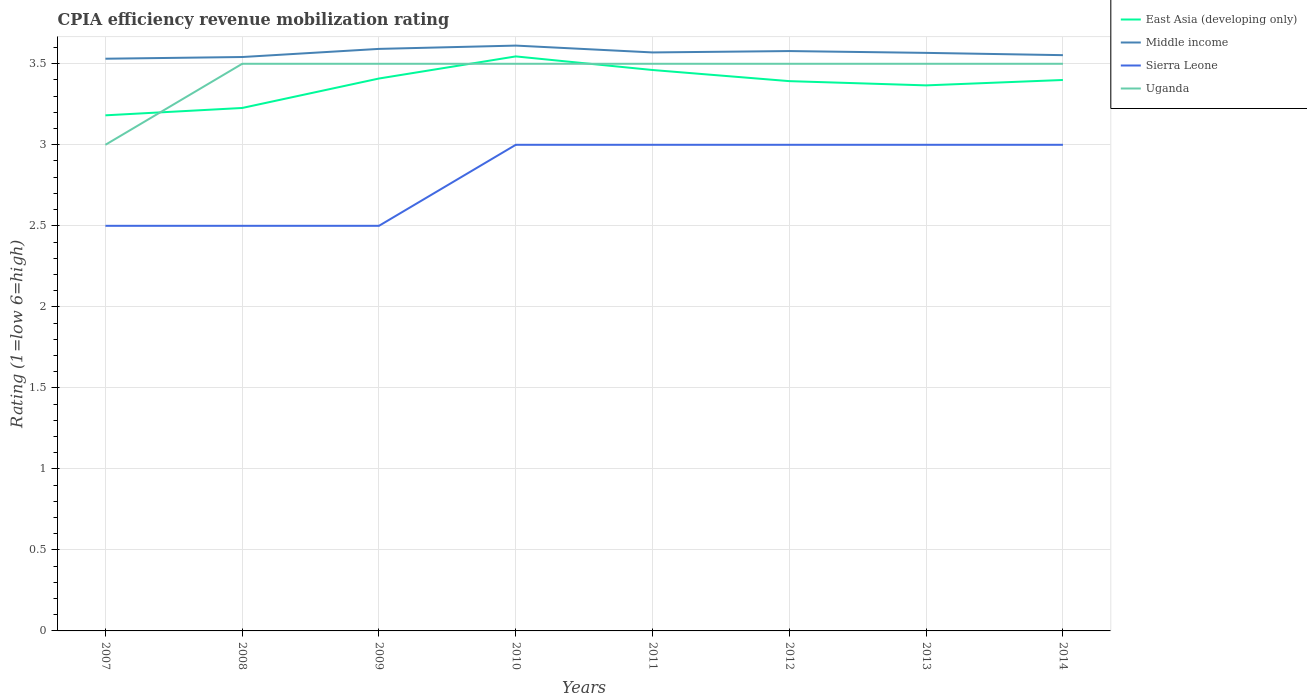How many different coloured lines are there?
Make the answer very short. 4. Does the line corresponding to Middle income intersect with the line corresponding to East Asia (developing only)?
Provide a short and direct response. No. Is the number of lines equal to the number of legend labels?
Provide a succinct answer. Yes. Across all years, what is the maximum CPIA rating in Sierra Leone?
Make the answer very short. 2.5. In which year was the CPIA rating in Sierra Leone maximum?
Provide a short and direct response. 2007. What is the difference between the highest and the second highest CPIA rating in East Asia (developing only)?
Offer a terse response. 0.36. What is the difference between the highest and the lowest CPIA rating in Middle income?
Offer a very short reply. 4. How many years are there in the graph?
Your answer should be compact. 8. What is the difference between two consecutive major ticks on the Y-axis?
Give a very brief answer. 0.5. Does the graph contain grids?
Your answer should be compact. Yes. Where does the legend appear in the graph?
Keep it short and to the point. Top right. What is the title of the graph?
Offer a terse response. CPIA efficiency revenue mobilization rating. What is the label or title of the X-axis?
Your answer should be very brief. Years. What is the Rating (1=low 6=high) of East Asia (developing only) in 2007?
Ensure brevity in your answer.  3.18. What is the Rating (1=low 6=high) of Middle income in 2007?
Ensure brevity in your answer.  3.53. What is the Rating (1=low 6=high) of Uganda in 2007?
Keep it short and to the point. 3. What is the Rating (1=low 6=high) in East Asia (developing only) in 2008?
Your answer should be very brief. 3.23. What is the Rating (1=low 6=high) in Middle income in 2008?
Ensure brevity in your answer.  3.54. What is the Rating (1=low 6=high) of East Asia (developing only) in 2009?
Ensure brevity in your answer.  3.41. What is the Rating (1=low 6=high) in Middle income in 2009?
Make the answer very short. 3.59. What is the Rating (1=low 6=high) in East Asia (developing only) in 2010?
Give a very brief answer. 3.55. What is the Rating (1=low 6=high) of Middle income in 2010?
Make the answer very short. 3.61. What is the Rating (1=low 6=high) of East Asia (developing only) in 2011?
Keep it short and to the point. 3.46. What is the Rating (1=low 6=high) in Middle income in 2011?
Give a very brief answer. 3.57. What is the Rating (1=low 6=high) in Uganda in 2011?
Your response must be concise. 3.5. What is the Rating (1=low 6=high) in East Asia (developing only) in 2012?
Your response must be concise. 3.39. What is the Rating (1=low 6=high) in Middle income in 2012?
Your response must be concise. 3.58. What is the Rating (1=low 6=high) in Sierra Leone in 2012?
Offer a terse response. 3. What is the Rating (1=low 6=high) of Uganda in 2012?
Offer a terse response. 3.5. What is the Rating (1=low 6=high) of East Asia (developing only) in 2013?
Offer a terse response. 3.37. What is the Rating (1=low 6=high) of Middle income in 2013?
Your answer should be compact. 3.57. What is the Rating (1=low 6=high) of Sierra Leone in 2013?
Make the answer very short. 3. What is the Rating (1=low 6=high) in Uganda in 2013?
Your answer should be very brief. 3.5. What is the Rating (1=low 6=high) of East Asia (developing only) in 2014?
Keep it short and to the point. 3.4. What is the Rating (1=low 6=high) of Middle income in 2014?
Keep it short and to the point. 3.55. What is the Rating (1=low 6=high) in Uganda in 2014?
Keep it short and to the point. 3.5. Across all years, what is the maximum Rating (1=low 6=high) in East Asia (developing only)?
Your answer should be very brief. 3.55. Across all years, what is the maximum Rating (1=low 6=high) of Middle income?
Keep it short and to the point. 3.61. Across all years, what is the maximum Rating (1=low 6=high) in Sierra Leone?
Your response must be concise. 3. Across all years, what is the maximum Rating (1=low 6=high) of Uganda?
Your response must be concise. 3.5. Across all years, what is the minimum Rating (1=low 6=high) of East Asia (developing only)?
Keep it short and to the point. 3.18. Across all years, what is the minimum Rating (1=low 6=high) in Middle income?
Your answer should be compact. 3.53. Across all years, what is the minimum Rating (1=low 6=high) of Uganda?
Offer a very short reply. 3. What is the total Rating (1=low 6=high) of East Asia (developing only) in the graph?
Provide a short and direct response. 26.98. What is the total Rating (1=low 6=high) of Middle income in the graph?
Offer a very short reply. 28.55. What is the total Rating (1=low 6=high) in Sierra Leone in the graph?
Make the answer very short. 22.5. What is the difference between the Rating (1=low 6=high) in East Asia (developing only) in 2007 and that in 2008?
Your answer should be very brief. -0.05. What is the difference between the Rating (1=low 6=high) in Middle income in 2007 and that in 2008?
Offer a terse response. -0.01. What is the difference between the Rating (1=low 6=high) in East Asia (developing only) in 2007 and that in 2009?
Your response must be concise. -0.23. What is the difference between the Rating (1=low 6=high) in Middle income in 2007 and that in 2009?
Make the answer very short. -0.06. What is the difference between the Rating (1=low 6=high) of Sierra Leone in 2007 and that in 2009?
Provide a short and direct response. 0. What is the difference between the Rating (1=low 6=high) in Uganda in 2007 and that in 2009?
Your response must be concise. -0.5. What is the difference between the Rating (1=low 6=high) of East Asia (developing only) in 2007 and that in 2010?
Make the answer very short. -0.36. What is the difference between the Rating (1=low 6=high) in Middle income in 2007 and that in 2010?
Ensure brevity in your answer.  -0.08. What is the difference between the Rating (1=low 6=high) in Uganda in 2007 and that in 2010?
Make the answer very short. -0.5. What is the difference between the Rating (1=low 6=high) in East Asia (developing only) in 2007 and that in 2011?
Provide a short and direct response. -0.28. What is the difference between the Rating (1=low 6=high) of Middle income in 2007 and that in 2011?
Offer a terse response. -0.04. What is the difference between the Rating (1=low 6=high) of East Asia (developing only) in 2007 and that in 2012?
Your answer should be very brief. -0.21. What is the difference between the Rating (1=low 6=high) in Middle income in 2007 and that in 2012?
Offer a terse response. -0.05. What is the difference between the Rating (1=low 6=high) in Sierra Leone in 2007 and that in 2012?
Make the answer very short. -0.5. What is the difference between the Rating (1=low 6=high) of East Asia (developing only) in 2007 and that in 2013?
Your answer should be compact. -0.18. What is the difference between the Rating (1=low 6=high) of Middle income in 2007 and that in 2013?
Offer a very short reply. -0.04. What is the difference between the Rating (1=low 6=high) in East Asia (developing only) in 2007 and that in 2014?
Offer a terse response. -0.22. What is the difference between the Rating (1=low 6=high) in Middle income in 2007 and that in 2014?
Your answer should be compact. -0.02. What is the difference between the Rating (1=low 6=high) in Sierra Leone in 2007 and that in 2014?
Your answer should be very brief. -0.5. What is the difference between the Rating (1=low 6=high) of East Asia (developing only) in 2008 and that in 2009?
Make the answer very short. -0.18. What is the difference between the Rating (1=low 6=high) of Middle income in 2008 and that in 2009?
Your response must be concise. -0.05. What is the difference between the Rating (1=low 6=high) of Uganda in 2008 and that in 2009?
Make the answer very short. 0. What is the difference between the Rating (1=low 6=high) in East Asia (developing only) in 2008 and that in 2010?
Ensure brevity in your answer.  -0.32. What is the difference between the Rating (1=low 6=high) of Middle income in 2008 and that in 2010?
Your answer should be compact. -0.07. What is the difference between the Rating (1=low 6=high) of East Asia (developing only) in 2008 and that in 2011?
Offer a terse response. -0.23. What is the difference between the Rating (1=low 6=high) of Middle income in 2008 and that in 2011?
Your answer should be compact. -0.03. What is the difference between the Rating (1=low 6=high) in Sierra Leone in 2008 and that in 2011?
Give a very brief answer. -0.5. What is the difference between the Rating (1=low 6=high) of Uganda in 2008 and that in 2011?
Offer a terse response. 0. What is the difference between the Rating (1=low 6=high) in East Asia (developing only) in 2008 and that in 2012?
Provide a short and direct response. -0.17. What is the difference between the Rating (1=low 6=high) of Middle income in 2008 and that in 2012?
Your answer should be compact. -0.04. What is the difference between the Rating (1=low 6=high) of Uganda in 2008 and that in 2012?
Give a very brief answer. 0. What is the difference between the Rating (1=low 6=high) of East Asia (developing only) in 2008 and that in 2013?
Provide a succinct answer. -0.14. What is the difference between the Rating (1=low 6=high) in Middle income in 2008 and that in 2013?
Offer a very short reply. -0.03. What is the difference between the Rating (1=low 6=high) of East Asia (developing only) in 2008 and that in 2014?
Your answer should be compact. -0.17. What is the difference between the Rating (1=low 6=high) in Middle income in 2008 and that in 2014?
Your response must be concise. -0.01. What is the difference between the Rating (1=low 6=high) of Uganda in 2008 and that in 2014?
Ensure brevity in your answer.  0. What is the difference between the Rating (1=low 6=high) of East Asia (developing only) in 2009 and that in 2010?
Keep it short and to the point. -0.14. What is the difference between the Rating (1=low 6=high) in Middle income in 2009 and that in 2010?
Provide a short and direct response. -0.02. What is the difference between the Rating (1=low 6=high) of East Asia (developing only) in 2009 and that in 2011?
Your answer should be compact. -0.05. What is the difference between the Rating (1=low 6=high) of Middle income in 2009 and that in 2011?
Your answer should be compact. 0.02. What is the difference between the Rating (1=low 6=high) in East Asia (developing only) in 2009 and that in 2012?
Give a very brief answer. 0.02. What is the difference between the Rating (1=low 6=high) in Middle income in 2009 and that in 2012?
Provide a succinct answer. 0.01. What is the difference between the Rating (1=low 6=high) of East Asia (developing only) in 2009 and that in 2013?
Offer a very short reply. 0.04. What is the difference between the Rating (1=low 6=high) in Middle income in 2009 and that in 2013?
Provide a succinct answer. 0.02. What is the difference between the Rating (1=low 6=high) of East Asia (developing only) in 2009 and that in 2014?
Provide a short and direct response. 0.01. What is the difference between the Rating (1=low 6=high) in Middle income in 2009 and that in 2014?
Provide a succinct answer. 0.04. What is the difference between the Rating (1=low 6=high) of Sierra Leone in 2009 and that in 2014?
Provide a succinct answer. -0.5. What is the difference between the Rating (1=low 6=high) of Uganda in 2009 and that in 2014?
Your response must be concise. 0. What is the difference between the Rating (1=low 6=high) in East Asia (developing only) in 2010 and that in 2011?
Provide a short and direct response. 0.08. What is the difference between the Rating (1=low 6=high) in Middle income in 2010 and that in 2011?
Ensure brevity in your answer.  0.04. What is the difference between the Rating (1=low 6=high) of Sierra Leone in 2010 and that in 2011?
Offer a very short reply. 0. What is the difference between the Rating (1=low 6=high) of East Asia (developing only) in 2010 and that in 2012?
Offer a very short reply. 0.15. What is the difference between the Rating (1=low 6=high) of Middle income in 2010 and that in 2012?
Provide a succinct answer. 0.03. What is the difference between the Rating (1=low 6=high) in Sierra Leone in 2010 and that in 2012?
Offer a terse response. 0. What is the difference between the Rating (1=low 6=high) of Uganda in 2010 and that in 2012?
Offer a terse response. 0. What is the difference between the Rating (1=low 6=high) of East Asia (developing only) in 2010 and that in 2013?
Ensure brevity in your answer.  0.18. What is the difference between the Rating (1=low 6=high) in Middle income in 2010 and that in 2013?
Provide a succinct answer. 0.04. What is the difference between the Rating (1=low 6=high) in Uganda in 2010 and that in 2013?
Provide a succinct answer. 0. What is the difference between the Rating (1=low 6=high) in East Asia (developing only) in 2010 and that in 2014?
Keep it short and to the point. 0.15. What is the difference between the Rating (1=low 6=high) in Middle income in 2010 and that in 2014?
Provide a succinct answer. 0.06. What is the difference between the Rating (1=low 6=high) in Sierra Leone in 2010 and that in 2014?
Your response must be concise. 0. What is the difference between the Rating (1=low 6=high) in Uganda in 2010 and that in 2014?
Offer a very short reply. 0. What is the difference between the Rating (1=low 6=high) of East Asia (developing only) in 2011 and that in 2012?
Your response must be concise. 0.07. What is the difference between the Rating (1=low 6=high) of Middle income in 2011 and that in 2012?
Your answer should be compact. -0.01. What is the difference between the Rating (1=low 6=high) in East Asia (developing only) in 2011 and that in 2013?
Offer a terse response. 0.09. What is the difference between the Rating (1=low 6=high) of Middle income in 2011 and that in 2013?
Your answer should be very brief. 0. What is the difference between the Rating (1=low 6=high) in Uganda in 2011 and that in 2013?
Provide a succinct answer. 0. What is the difference between the Rating (1=low 6=high) in East Asia (developing only) in 2011 and that in 2014?
Your answer should be very brief. 0.06. What is the difference between the Rating (1=low 6=high) in Middle income in 2011 and that in 2014?
Your answer should be compact. 0.02. What is the difference between the Rating (1=low 6=high) in Sierra Leone in 2011 and that in 2014?
Provide a short and direct response. 0. What is the difference between the Rating (1=low 6=high) of East Asia (developing only) in 2012 and that in 2013?
Offer a terse response. 0.03. What is the difference between the Rating (1=low 6=high) in Middle income in 2012 and that in 2013?
Offer a very short reply. 0.01. What is the difference between the Rating (1=low 6=high) in Sierra Leone in 2012 and that in 2013?
Ensure brevity in your answer.  0. What is the difference between the Rating (1=low 6=high) in Uganda in 2012 and that in 2013?
Offer a terse response. 0. What is the difference between the Rating (1=low 6=high) of East Asia (developing only) in 2012 and that in 2014?
Make the answer very short. -0.01. What is the difference between the Rating (1=low 6=high) in Middle income in 2012 and that in 2014?
Your response must be concise. 0.03. What is the difference between the Rating (1=low 6=high) in Sierra Leone in 2012 and that in 2014?
Your response must be concise. 0. What is the difference between the Rating (1=low 6=high) in Uganda in 2012 and that in 2014?
Keep it short and to the point. 0. What is the difference between the Rating (1=low 6=high) of East Asia (developing only) in 2013 and that in 2014?
Offer a very short reply. -0.03. What is the difference between the Rating (1=low 6=high) of Middle income in 2013 and that in 2014?
Provide a short and direct response. 0.01. What is the difference between the Rating (1=low 6=high) in Sierra Leone in 2013 and that in 2014?
Give a very brief answer. 0. What is the difference between the Rating (1=low 6=high) of Uganda in 2013 and that in 2014?
Keep it short and to the point. 0. What is the difference between the Rating (1=low 6=high) in East Asia (developing only) in 2007 and the Rating (1=low 6=high) in Middle income in 2008?
Provide a short and direct response. -0.36. What is the difference between the Rating (1=low 6=high) of East Asia (developing only) in 2007 and the Rating (1=low 6=high) of Sierra Leone in 2008?
Your answer should be very brief. 0.68. What is the difference between the Rating (1=low 6=high) in East Asia (developing only) in 2007 and the Rating (1=low 6=high) in Uganda in 2008?
Provide a succinct answer. -0.32. What is the difference between the Rating (1=low 6=high) in Middle income in 2007 and the Rating (1=low 6=high) in Sierra Leone in 2008?
Provide a succinct answer. 1.03. What is the difference between the Rating (1=low 6=high) of Middle income in 2007 and the Rating (1=low 6=high) of Uganda in 2008?
Your answer should be very brief. 0.03. What is the difference between the Rating (1=low 6=high) in East Asia (developing only) in 2007 and the Rating (1=low 6=high) in Middle income in 2009?
Provide a short and direct response. -0.41. What is the difference between the Rating (1=low 6=high) of East Asia (developing only) in 2007 and the Rating (1=low 6=high) of Sierra Leone in 2009?
Ensure brevity in your answer.  0.68. What is the difference between the Rating (1=low 6=high) in East Asia (developing only) in 2007 and the Rating (1=low 6=high) in Uganda in 2009?
Make the answer very short. -0.32. What is the difference between the Rating (1=low 6=high) in Middle income in 2007 and the Rating (1=low 6=high) in Sierra Leone in 2009?
Your answer should be very brief. 1.03. What is the difference between the Rating (1=low 6=high) in Middle income in 2007 and the Rating (1=low 6=high) in Uganda in 2009?
Make the answer very short. 0.03. What is the difference between the Rating (1=low 6=high) of East Asia (developing only) in 2007 and the Rating (1=low 6=high) of Middle income in 2010?
Offer a terse response. -0.43. What is the difference between the Rating (1=low 6=high) of East Asia (developing only) in 2007 and the Rating (1=low 6=high) of Sierra Leone in 2010?
Your response must be concise. 0.18. What is the difference between the Rating (1=low 6=high) in East Asia (developing only) in 2007 and the Rating (1=low 6=high) in Uganda in 2010?
Keep it short and to the point. -0.32. What is the difference between the Rating (1=low 6=high) in Middle income in 2007 and the Rating (1=low 6=high) in Sierra Leone in 2010?
Your response must be concise. 0.53. What is the difference between the Rating (1=low 6=high) in Middle income in 2007 and the Rating (1=low 6=high) in Uganda in 2010?
Provide a short and direct response. 0.03. What is the difference between the Rating (1=low 6=high) of East Asia (developing only) in 2007 and the Rating (1=low 6=high) of Middle income in 2011?
Provide a short and direct response. -0.39. What is the difference between the Rating (1=low 6=high) of East Asia (developing only) in 2007 and the Rating (1=low 6=high) of Sierra Leone in 2011?
Your response must be concise. 0.18. What is the difference between the Rating (1=low 6=high) of East Asia (developing only) in 2007 and the Rating (1=low 6=high) of Uganda in 2011?
Offer a very short reply. -0.32. What is the difference between the Rating (1=low 6=high) in Middle income in 2007 and the Rating (1=low 6=high) in Sierra Leone in 2011?
Keep it short and to the point. 0.53. What is the difference between the Rating (1=low 6=high) in Middle income in 2007 and the Rating (1=low 6=high) in Uganda in 2011?
Give a very brief answer. 0.03. What is the difference between the Rating (1=low 6=high) in East Asia (developing only) in 2007 and the Rating (1=low 6=high) in Middle income in 2012?
Your answer should be very brief. -0.4. What is the difference between the Rating (1=low 6=high) in East Asia (developing only) in 2007 and the Rating (1=low 6=high) in Sierra Leone in 2012?
Give a very brief answer. 0.18. What is the difference between the Rating (1=low 6=high) of East Asia (developing only) in 2007 and the Rating (1=low 6=high) of Uganda in 2012?
Give a very brief answer. -0.32. What is the difference between the Rating (1=low 6=high) in Middle income in 2007 and the Rating (1=low 6=high) in Sierra Leone in 2012?
Your answer should be compact. 0.53. What is the difference between the Rating (1=low 6=high) in Middle income in 2007 and the Rating (1=low 6=high) in Uganda in 2012?
Offer a very short reply. 0.03. What is the difference between the Rating (1=low 6=high) of East Asia (developing only) in 2007 and the Rating (1=low 6=high) of Middle income in 2013?
Ensure brevity in your answer.  -0.39. What is the difference between the Rating (1=low 6=high) of East Asia (developing only) in 2007 and the Rating (1=low 6=high) of Sierra Leone in 2013?
Ensure brevity in your answer.  0.18. What is the difference between the Rating (1=low 6=high) in East Asia (developing only) in 2007 and the Rating (1=low 6=high) in Uganda in 2013?
Offer a terse response. -0.32. What is the difference between the Rating (1=low 6=high) in Middle income in 2007 and the Rating (1=low 6=high) in Sierra Leone in 2013?
Your response must be concise. 0.53. What is the difference between the Rating (1=low 6=high) of Middle income in 2007 and the Rating (1=low 6=high) of Uganda in 2013?
Offer a very short reply. 0.03. What is the difference between the Rating (1=low 6=high) of Sierra Leone in 2007 and the Rating (1=low 6=high) of Uganda in 2013?
Offer a very short reply. -1. What is the difference between the Rating (1=low 6=high) in East Asia (developing only) in 2007 and the Rating (1=low 6=high) in Middle income in 2014?
Provide a succinct answer. -0.37. What is the difference between the Rating (1=low 6=high) in East Asia (developing only) in 2007 and the Rating (1=low 6=high) in Sierra Leone in 2014?
Provide a short and direct response. 0.18. What is the difference between the Rating (1=low 6=high) of East Asia (developing only) in 2007 and the Rating (1=low 6=high) of Uganda in 2014?
Provide a short and direct response. -0.32. What is the difference between the Rating (1=low 6=high) of Middle income in 2007 and the Rating (1=low 6=high) of Sierra Leone in 2014?
Make the answer very short. 0.53. What is the difference between the Rating (1=low 6=high) of Middle income in 2007 and the Rating (1=low 6=high) of Uganda in 2014?
Keep it short and to the point. 0.03. What is the difference between the Rating (1=low 6=high) of Sierra Leone in 2007 and the Rating (1=low 6=high) of Uganda in 2014?
Your answer should be compact. -1. What is the difference between the Rating (1=low 6=high) in East Asia (developing only) in 2008 and the Rating (1=low 6=high) in Middle income in 2009?
Make the answer very short. -0.36. What is the difference between the Rating (1=low 6=high) of East Asia (developing only) in 2008 and the Rating (1=low 6=high) of Sierra Leone in 2009?
Keep it short and to the point. 0.73. What is the difference between the Rating (1=low 6=high) in East Asia (developing only) in 2008 and the Rating (1=low 6=high) in Uganda in 2009?
Offer a very short reply. -0.27. What is the difference between the Rating (1=low 6=high) in Middle income in 2008 and the Rating (1=low 6=high) in Sierra Leone in 2009?
Ensure brevity in your answer.  1.04. What is the difference between the Rating (1=low 6=high) of Middle income in 2008 and the Rating (1=low 6=high) of Uganda in 2009?
Your answer should be compact. 0.04. What is the difference between the Rating (1=low 6=high) of Sierra Leone in 2008 and the Rating (1=low 6=high) of Uganda in 2009?
Offer a very short reply. -1. What is the difference between the Rating (1=low 6=high) of East Asia (developing only) in 2008 and the Rating (1=low 6=high) of Middle income in 2010?
Give a very brief answer. -0.39. What is the difference between the Rating (1=low 6=high) in East Asia (developing only) in 2008 and the Rating (1=low 6=high) in Sierra Leone in 2010?
Keep it short and to the point. 0.23. What is the difference between the Rating (1=low 6=high) in East Asia (developing only) in 2008 and the Rating (1=low 6=high) in Uganda in 2010?
Your answer should be compact. -0.27. What is the difference between the Rating (1=low 6=high) of Middle income in 2008 and the Rating (1=low 6=high) of Sierra Leone in 2010?
Provide a short and direct response. 0.54. What is the difference between the Rating (1=low 6=high) of Middle income in 2008 and the Rating (1=low 6=high) of Uganda in 2010?
Keep it short and to the point. 0.04. What is the difference between the Rating (1=low 6=high) in Sierra Leone in 2008 and the Rating (1=low 6=high) in Uganda in 2010?
Keep it short and to the point. -1. What is the difference between the Rating (1=low 6=high) in East Asia (developing only) in 2008 and the Rating (1=low 6=high) in Middle income in 2011?
Keep it short and to the point. -0.34. What is the difference between the Rating (1=low 6=high) of East Asia (developing only) in 2008 and the Rating (1=low 6=high) of Sierra Leone in 2011?
Keep it short and to the point. 0.23. What is the difference between the Rating (1=low 6=high) of East Asia (developing only) in 2008 and the Rating (1=low 6=high) of Uganda in 2011?
Your answer should be compact. -0.27. What is the difference between the Rating (1=low 6=high) of Middle income in 2008 and the Rating (1=low 6=high) of Sierra Leone in 2011?
Ensure brevity in your answer.  0.54. What is the difference between the Rating (1=low 6=high) in Middle income in 2008 and the Rating (1=low 6=high) in Uganda in 2011?
Make the answer very short. 0.04. What is the difference between the Rating (1=low 6=high) of Sierra Leone in 2008 and the Rating (1=low 6=high) of Uganda in 2011?
Give a very brief answer. -1. What is the difference between the Rating (1=low 6=high) of East Asia (developing only) in 2008 and the Rating (1=low 6=high) of Middle income in 2012?
Make the answer very short. -0.35. What is the difference between the Rating (1=low 6=high) in East Asia (developing only) in 2008 and the Rating (1=low 6=high) in Sierra Leone in 2012?
Keep it short and to the point. 0.23. What is the difference between the Rating (1=low 6=high) of East Asia (developing only) in 2008 and the Rating (1=low 6=high) of Uganda in 2012?
Your answer should be compact. -0.27. What is the difference between the Rating (1=low 6=high) of Middle income in 2008 and the Rating (1=low 6=high) of Sierra Leone in 2012?
Ensure brevity in your answer.  0.54. What is the difference between the Rating (1=low 6=high) of Middle income in 2008 and the Rating (1=low 6=high) of Uganda in 2012?
Give a very brief answer. 0.04. What is the difference between the Rating (1=low 6=high) of Sierra Leone in 2008 and the Rating (1=low 6=high) of Uganda in 2012?
Provide a succinct answer. -1. What is the difference between the Rating (1=low 6=high) of East Asia (developing only) in 2008 and the Rating (1=low 6=high) of Middle income in 2013?
Keep it short and to the point. -0.34. What is the difference between the Rating (1=low 6=high) in East Asia (developing only) in 2008 and the Rating (1=low 6=high) in Sierra Leone in 2013?
Offer a terse response. 0.23. What is the difference between the Rating (1=low 6=high) of East Asia (developing only) in 2008 and the Rating (1=low 6=high) of Uganda in 2013?
Provide a succinct answer. -0.27. What is the difference between the Rating (1=low 6=high) of Middle income in 2008 and the Rating (1=low 6=high) of Sierra Leone in 2013?
Provide a short and direct response. 0.54. What is the difference between the Rating (1=low 6=high) in Middle income in 2008 and the Rating (1=low 6=high) in Uganda in 2013?
Your answer should be compact. 0.04. What is the difference between the Rating (1=low 6=high) of East Asia (developing only) in 2008 and the Rating (1=low 6=high) of Middle income in 2014?
Your answer should be very brief. -0.33. What is the difference between the Rating (1=low 6=high) in East Asia (developing only) in 2008 and the Rating (1=low 6=high) in Sierra Leone in 2014?
Keep it short and to the point. 0.23. What is the difference between the Rating (1=low 6=high) of East Asia (developing only) in 2008 and the Rating (1=low 6=high) of Uganda in 2014?
Offer a very short reply. -0.27. What is the difference between the Rating (1=low 6=high) in Middle income in 2008 and the Rating (1=low 6=high) in Sierra Leone in 2014?
Make the answer very short. 0.54. What is the difference between the Rating (1=low 6=high) of Middle income in 2008 and the Rating (1=low 6=high) of Uganda in 2014?
Provide a succinct answer. 0.04. What is the difference between the Rating (1=low 6=high) in Sierra Leone in 2008 and the Rating (1=low 6=high) in Uganda in 2014?
Your answer should be very brief. -1. What is the difference between the Rating (1=low 6=high) of East Asia (developing only) in 2009 and the Rating (1=low 6=high) of Middle income in 2010?
Offer a very short reply. -0.2. What is the difference between the Rating (1=low 6=high) in East Asia (developing only) in 2009 and the Rating (1=low 6=high) in Sierra Leone in 2010?
Keep it short and to the point. 0.41. What is the difference between the Rating (1=low 6=high) of East Asia (developing only) in 2009 and the Rating (1=low 6=high) of Uganda in 2010?
Your answer should be very brief. -0.09. What is the difference between the Rating (1=low 6=high) in Middle income in 2009 and the Rating (1=low 6=high) in Sierra Leone in 2010?
Provide a succinct answer. 0.59. What is the difference between the Rating (1=low 6=high) in Middle income in 2009 and the Rating (1=low 6=high) in Uganda in 2010?
Your answer should be compact. 0.09. What is the difference between the Rating (1=low 6=high) in East Asia (developing only) in 2009 and the Rating (1=low 6=high) in Middle income in 2011?
Provide a short and direct response. -0.16. What is the difference between the Rating (1=low 6=high) of East Asia (developing only) in 2009 and the Rating (1=low 6=high) of Sierra Leone in 2011?
Provide a succinct answer. 0.41. What is the difference between the Rating (1=low 6=high) in East Asia (developing only) in 2009 and the Rating (1=low 6=high) in Uganda in 2011?
Give a very brief answer. -0.09. What is the difference between the Rating (1=low 6=high) in Middle income in 2009 and the Rating (1=low 6=high) in Sierra Leone in 2011?
Your response must be concise. 0.59. What is the difference between the Rating (1=low 6=high) in Middle income in 2009 and the Rating (1=low 6=high) in Uganda in 2011?
Your response must be concise. 0.09. What is the difference between the Rating (1=low 6=high) in East Asia (developing only) in 2009 and the Rating (1=low 6=high) in Middle income in 2012?
Your answer should be compact. -0.17. What is the difference between the Rating (1=low 6=high) in East Asia (developing only) in 2009 and the Rating (1=low 6=high) in Sierra Leone in 2012?
Offer a very short reply. 0.41. What is the difference between the Rating (1=low 6=high) of East Asia (developing only) in 2009 and the Rating (1=low 6=high) of Uganda in 2012?
Provide a succinct answer. -0.09. What is the difference between the Rating (1=low 6=high) in Middle income in 2009 and the Rating (1=low 6=high) in Sierra Leone in 2012?
Provide a succinct answer. 0.59. What is the difference between the Rating (1=low 6=high) of Middle income in 2009 and the Rating (1=low 6=high) of Uganda in 2012?
Provide a succinct answer. 0.09. What is the difference between the Rating (1=low 6=high) in Sierra Leone in 2009 and the Rating (1=low 6=high) in Uganda in 2012?
Your answer should be compact. -1. What is the difference between the Rating (1=low 6=high) in East Asia (developing only) in 2009 and the Rating (1=low 6=high) in Middle income in 2013?
Your response must be concise. -0.16. What is the difference between the Rating (1=low 6=high) in East Asia (developing only) in 2009 and the Rating (1=low 6=high) in Sierra Leone in 2013?
Provide a succinct answer. 0.41. What is the difference between the Rating (1=low 6=high) of East Asia (developing only) in 2009 and the Rating (1=low 6=high) of Uganda in 2013?
Keep it short and to the point. -0.09. What is the difference between the Rating (1=low 6=high) in Middle income in 2009 and the Rating (1=low 6=high) in Sierra Leone in 2013?
Give a very brief answer. 0.59. What is the difference between the Rating (1=low 6=high) in Middle income in 2009 and the Rating (1=low 6=high) in Uganda in 2013?
Keep it short and to the point. 0.09. What is the difference between the Rating (1=low 6=high) of East Asia (developing only) in 2009 and the Rating (1=low 6=high) of Middle income in 2014?
Provide a succinct answer. -0.14. What is the difference between the Rating (1=low 6=high) in East Asia (developing only) in 2009 and the Rating (1=low 6=high) in Sierra Leone in 2014?
Your answer should be very brief. 0.41. What is the difference between the Rating (1=low 6=high) of East Asia (developing only) in 2009 and the Rating (1=low 6=high) of Uganda in 2014?
Give a very brief answer. -0.09. What is the difference between the Rating (1=low 6=high) in Middle income in 2009 and the Rating (1=low 6=high) in Sierra Leone in 2014?
Provide a short and direct response. 0.59. What is the difference between the Rating (1=low 6=high) of Middle income in 2009 and the Rating (1=low 6=high) of Uganda in 2014?
Provide a short and direct response. 0.09. What is the difference between the Rating (1=low 6=high) in Sierra Leone in 2009 and the Rating (1=low 6=high) in Uganda in 2014?
Ensure brevity in your answer.  -1. What is the difference between the Rating (1=low 6=high) of East Asia (developing only) in 2010 and the Rating (1=low 6=high) of Middle income in 2011?
Give a very brief answer. -0.02. What is the difference between the Rating (1=low 6=high) in East Asia (developing only) in 2010 and the Rating (1=low 6=high) in Sierra Leone in 2011?
Make the answer very short. 0.55. What is the difference between the Rating (1=low 6=high) in East Asia (developing only) in 2010 and the Rating (1=low 6=high) in Uganda in 2011?
Your answer should be very brief. 0.05. What is the difference between the Rating (1=low 6=high) of Middle income in 2010 and the Rating (1=low 6=high) of Sierra Leone in 2011?
Your answer should be compact. 0.61. What is the difference between the Rating (1=low 6=high) in Middle income in 2010 and the Rating (1=low 6=high) in Uganda in 2011?
Your response must be concise. 0.11. What is the difference between the Rating (1=low 6=high) in Sierra Leone in 2010 and the Rating (1=low 6=high) in Uganda in 2011?
Keep it short and to the point. -0.5. What is the difference between the Rating (1=low 6=high) of East Asia (developing only) in 2010 and the Rating (1=low 6=high) of Middle income in 2012?
Provide a succinct answer. -0.03. What is the difference between the Rating (1=low 6=high) of East Asia (developing only) in 2010 and the Rating (1=low 6=high) of Sierra Leone in 2012?
Make the answer very short. 0.55. What is the difference between the Rating (1=low 6=high) in East Asia (developing only) in 2010 and the Rating (1=low 6=high) in Uganda in 2012?
Your answer should be compact. 0.05. What is the difference between the Rating (1=low 6=high) in Middle income in 2010 and the Rating (1=low 6=high) in Sierra Leone in 2012?
Keep it short and to the point. 0.61. What is the difference between the Rating (1=low 6=high) in Middle income in 2010 and the Rating (1=low 6=high) in Uganda in 2012?
Provide a short and direct response. 0.11. What is the difference between the Rating (1=low 6=high) of Sierra Leone in 2010 and the Rating (1=low 6=high) of Uganda in 2012?
Give a very brief answer. -0.5. What is the difference between the Rating (1=low 6=high) in East Asia (developing only) in 2010 and the Rating (1=low 6=high) in Middle income in 2013?
Provide a succinct answer. -0.02. What is the difference between the Rating (1=low 6=high) of East Asia (developing only) in 2010 and the Rating (1=low 6=high) of Sierra Leone in 2013?
Offer a very short reply. 0.55. What is the difference between the Rating (1=low 6=high) of East Asia (developing only) in 2010 and the Rating (1=low 6=high) of Uganda in 2013?
Your response must be concise. 0.05. What is the difference between the Rating (1=low 6=high) in Middle income in 2010 and the Rating (1=low 6=high) in Sierra Leone in 2013?
Keep it short and to the point. 0.61. What is the difference between the Rating (1=low 6=high) in Middle income in 2010 and the Rating (1=low 6=high) in Uganda in 2013?
Your answer should be compact. 0.11. What is the difference between the Rating (1=low 6=high) in East Asia (developing only) in 2010 and the Rating (1=low 6=high) in Middle income in 2014?
Offer a very short reply. -0.01. What is the difference between the Rating (1=low 6=high) of East Asia (developing only) in 2010 and the Rating (1=low 6=high) of Sierra Leone in 2014?
Provide a short and direct response. 0.55. What is the difference between the Rating (1=low 6=high) of East Asia (developing only) in 2010 and the Rating (1=low 6=high) of Uganda in 2014?
Your response must be concise. 0.05. What is the difference between the Rating (1=low 6=high) of Middle income in 2010 and the Rating (1=low 6=high) of Sierra Leone in 2014?
Provide a succinct answer. 0.61. What is the difference between the Rating (1=low 6=high) in Middle income in 2010 and the Rating (1=low 6=high) in Uganda in 2014?
Your answer should be very brief. 0.11. What is the difference between the Rating (1=low 6=high) of East Asia (developing only) in 2011 and the Rating (1=low 6=high) of Middle income in 2012?
Provide a short and direct response. -0.12. What is the difference between the Rating (1=low 6=high) in East Asia (developing only) in 2011 and the Rating (1=low 6=high) in Sierra Leone in 2012?
Ensure brevity in your answer.  0.46. What is the difference between the Rating (1=low 6=high) of East Asia (developing only) in 2011 and the Rating (1=low 6=high) of Uganda in 2012?
Your response must be concise. -0.04. What is the difference between the Rating (1=low 6=high) in Middle income in 2011 and the Rating (1=low 6=high) in Sierra Leone in 2012?
Make the answer very short. 0.57. What is the difference between the Rating (1=low 6=high) in Middle income in 2011 and the Rating (1=low 6=high) in Uganda in 2012?
Give a very brief answer. 0.07. What is the difference between the Rating (1=low 6=high) of Sierra Leone in 2011 and the Rating (1=low 6=high) of Uganda in 2012?
Provide a succinct answer. -0.5. What is the difference between the Rating (1=low 6=high) of East Asia (developing only) in 2011 and the Rating (1=low 6=high) of Middle income in 2013?
Give a very brief answer. -0.11. What is the difference between the Rating (1=low 6=high) in East Asia (developing only) in 2011 and the Rating (1=low 6=high) in Sierra Leone in 2013?
Your response must be concise. 0.46. What is the difference between the Rating (1=low 6=high) in East Asia (developing only) in 2011 and the Rating (1=low 6=high) in Uganda in 2013?
Keep it short and to the point. -0.04. What is the difference between the Rating (1=low 6=high) of Middle income in 2011 and the Rating (1=low 6=high) of Sierra Leone in 2013?
Give a very brief answer. 0.57. What is the difference between the Rating (1=low 6=high) of Middle income in 2011 and the Rating (1=low 6=high) of Uganda in 2013?
Your answer should be very brief. 0.07. What is the difference between the Rating (1=low 6=high) in Sierra Leone in 2011 and the Rating (1=low 6=high) in Uganda in 2013?
Offer a very short reply. -0.5. What is the difference between the Rating (1=low 6=high) in East Asia (developing only) in 2011 and the Rating (1=low 6=high) in Middle income in 2014?
Give a very brief answer. -0.09. What is the difference between the Rating (1=low 6=high) of East Asia (developing only) in 2011 and the Rating (1=low 6=high) of Sierra Leone in 2014?
Your answer should be compact. 0.46. What is the difference between the Rating (1=low 6=high) in East Asia (developing only) in 2011 and the Rating (1=low 6=high) in Uganda in 2014?
Make the answer very short. -0.04. What is the difference between the Rating (1=low 6=high) in Middle income in 2011 and the Rating (1=low 6=high) in Sierra Leone in 2014?
Provide a short and direct response. 0.57. What is the difference between the Rating (1=low 6=high) in Middle income in 2011 and the Rating (1=low 6=high) in Uganda in 2014?
Provide a short and direct response. 0.07. What is the difference between the Rating (1=low 6=high) in Sierra Leone in 2011 and the Rating (1=low 6=high) in Uganda in 2014?
Give a very brief answer. -0.5. What is the difference between the Rating (1=low 6=high) in East Asia (developing only) in 2012 and the Rating (1=low 6=high) in Middle income in 2013?
Your response must be concise. -0.17. What is the difference between the Rating (1=low 6=high) of East Asia (developing only) in 2012 and the Rating (1=low 6=high) of Sierra Leone in 2013?
Give a very brief answer. 0.39. What is the difference between the Rating (1=low 6=high) in East Asia (developing only) in 2012 and the Rating (1=low 6=high) in Uganda in 2013?
Your answer should be very brief. -0.11. What is the difference between the Rating (1=low 6=high) of Middle income in 2012 and the Rating (1=low 6=high) of Sierra Leone in 2013?
Keep it short and to the point. 0.58. What is the difference between the Rating (1=low 6=high) in Middle income in 2012 and the Rating (1=low 6=high) in Uganda in 2013?
Offer a very short reply. 0.08. What is the difference between the Rating (1=low 6=high) of Sierra Leone in 2012 and the Rating (1=low 6=high) of Uganda in 2013?
Provide a succinct answer. -0.5. What is the difference between the Rating (1=low 6=high) in East Asia (developing only) in 2012 and the Rating (1=low 6=high) in Middle income in 2014?
Make the answer very short. -0.16. What is the difference between the Rating (1=low 6=high) of East Asia (developing only) in 2012 and the Rating (1=low 6=high) of Sierra Leone in 2014?
Your answer should be very brief. 0.39. What is the difference between the Rating (1=low 6=high) in East Asia (developing only) in 2012 and the Rating (1=low 6=high) in Uganda in 2014?
Give a very brief answer. -0.11. What is the difference between the Rating (1=low 6=high) of Middle income in 2012 and the Rating (1=low 6=high) of Sierra Leone in 2014?
Keep it short and to the point. 0.58. What is the difference between the Rating (1=low 6=high) in Middle income in 2012 and the Rating (1=low 6=high) in Uganda in 2014?
Provide a short and direct response. 0.08. What is the difference between the Rating (1=low 6=high) in Sierra Leone in 2012 and the Rating (1=low 6=high) in Uganda in 2014?
Provide a succinct answer. -0.5. What is the difference between the Rating (1=low 6=high) of East Asia (developing only) in 2013 and the Rating (1=low 6=high) of Middle income in 2014?
Keep it short and to the point. -0.19. What is the difference between the Rating (1=low 6=high) in East Asia (developing only) in 2013 and the Rating (1=low 6=high) in Sierra Leone in 2014?
Offer a terse response. 0.37. What is the difference between the Rating (1=low 6=high) of East Asia (developing only) in 2013 and the Rating (1=low 6=high) of Uganda in 2014?
Give a very brief answer. -0.13. What is the difference between the Rating (1=low 6=high) in Middle income in 2013 and the Rating (1=low 6=high) in Sierra Leone in 2014?
Provide a short and direct response. 0.57. What is the difference between the Rating (1=low 6=high) of Middle income in 2013 and the Rating (1=low 6=high) of Uganda in 2014?
Your answer should be very brief. 0.07. What is the difference between the Rating (1=low 6=high) of Sierra Leone in 2013 and the Rating (1=low 6=high) of Uganda in 2014?
Your response must be concise. -0.5. What is the average Rating (1=low 6=high) of East Asia (developing only) per year?
Your response must be concise. 3.37. What is the average Rating (1=low 6=high) of Middle income per year?
Offer a terse response. 3.57. What is the average Rating (1=low 6=high) in Sierra Leone per year?
Your answer should be compact. 2.81. What is the average Rating (1=low 6=high) of Uganda per year?
Your answer should be compact. 3.44. In the year 2007, what is the difference between the Rating (1=low 6=high) of East Asia (developing only) and Rating (1=low 6=high) of Middle income?
Ensure brevity in your answer.  -0.35. In the year 2007, what is the difference between the Rating (1=low 6=high) in East Asia (developing only) and Rating (1=low 6=high) in Sierra Leone?
Ensure brevity in your answer.  0.68. In the year 2007, what is the difference between the Rating (1=low 6=high) of East Asia (developing only) and Rating (1=low 6=high) of Uganda?
Offer a terse response. 0.18. In the year 2007, what is the difference between the Rating (1=low 6=high) in Middle income and Rating (1=low 6=high) in Sierra Leone?
Provide a short and direct response. 1.03. In the year 2007, what is the difference between the Rating (1=low 6=high) in Middle income and Rating (1=low 6=high) in Uganda?
Offer a very short reply. 0.53. In the year 2008, what is the difference between the Rating (1=low 6=high) of East Asia (developing only) and Rating (1=low 6=high) of Middle income?
Provide a succinct answer. -0.31. In the year 2008, what is the difference between the Rating (1=low 6=high) of East Asia (developing only) and Rating (1=low 6=high) of Sierra Leone?
Your answer should be very brief. 0.73. In the year 2008, what is the difference between the Rating (1=low 6=high) of East Asia (developing only) and Rating (1=low 6=high) of Uganda?
Provide a succinct answer. -0.27. In the year 2008, what is the difference between the Rating (1=low 6=high) of Middle income and Rating (1=low 6=high) of Sierra Leone?
Keep it short and to the point. 1.04. In the year 2008, what is the difference between the Rating (1=low 6=high) of Middle income and Rating (1=low 6=high) of Uganda?
Offer a very short reply. 0.04. In the year 2008, what is the difference between the Rating (1=low 6=high) of Sierra Leone and Rating (1=low 6=high) of Uganda?
Ensure brevity in your answer.  -1. In the year 2009, what is the difference between the Rating (1=low 6=high) in East Asia (developing only) and Rating (1=low 6=high) in Middle income?
Provide a succinct answer. -0.18. In the year 2009, what is the difference between the Rating (1=low 6=high) of East Asia (developing only) and Rating (1=low 6=high) of Uganda?
Your answer should be compact. -0.09. In the year 2009, what is the difference between the Rating (1=low 6=high) of Middle income and Rating (1=low 6=high) of Sierra Leone?
Your answer should be compact. 1.09. In the year 2009, what is the difference between the Rating (1=low 6=high) of Middle income and Rating (1=low 6=high) of Uganda?
Give a very brief answer. 0.09. In the year 2010, what is the difference between the Rating (1=low 6=high) of East Asia (developing only) and Rating (1=low 6=high) of Middle income?
Your response must be concise. -0.07. In the year 2010, what is the difference between the Rating (1=low 6=high) in East Asia (developing only) and Rating (1=low 6=high) in Sierra Leone?
Keep it short and to the point. 0.55. In the year 2010, what is the difference between the Rating (1=low 6=high) of East Asia (developing only) and Rating (1=low 6=high) of Uganda?
Provide a succinct answer. 0.05. In the year 2010, what is the difference between the Rating (1=low 6=high) of Middle income and Rating (1=low 6=high) of Sierra Leone?
Give a very brief answer. 0.61. In the year 2010, what is the difference between the Rating (1=low 6=high) in Middle income and Rating (1=low 6=high) in Uganda?
Give a very brief answer. 0.11. In the year 2010, what is the difference between the Rating (1=low 6=high) of Sierra Leone and Rating (1=low 6=high) of Uganda?
Offer a very short reply. -0.5. In the year 2011, what is the difference between the Rating (1=low 6=high) in East Asia (developing only) and Rating (1=low 6=high) in Middle income?
Your response must be concise. -0.11. In the year 2011, what is the difference between the Rating (1=low 6=high) of East Asia (developing only) and Rating (1=low 6=high) of Sierra Leone?
Provide a succinct answer. 0.46. In the year 2011, what is the difference between the Rating (1=low 6=high) in East Asia (developing only) and Rating (1=low 6=high) in Uganda?
Your response must be concise. -0.04. In the year 2011, what is the difference between the Rating (1=low 6=high) of Middle income and Rating (1=low 6=high) of Sierra Leone?
Ensure brevity in your answer.  0.57. In the year 2011, what is the difference between the Rating (1=low 6=high) of Middle income and Rating (1=low 6=high) of Uganda?
Keep it short and to the point. 0.07. In the year 2012, what is the difference between the Rating (1=low 6=high) in East Asia (developing only) and Rating (1=low 6=high) in Middle income?
Give a very brief answer. -0.19. In the year 2012, what is the difference between the Rating (1=low 6=high) in East Asia (developing only) and Rating (1=low 6=high) in Sierra Leone?
Give a very brief answer. 0.39. In the year 2012, what is the difference between the Rating (1=low 6=high) of East Asia (developing only) and Rating (1=low 6=high) of Uganda?
Make the answer very short. -0.11. In the year 2012, what is the difference between the Rating (1=low 6=high) in Middle income and Rating (1=low 6=high) in Sierra Leone?
Keep it short and to the point. 0.58. In the year 2012, what is the difference between the Rating (1=low 6=high) in Middle income and Rating (1=low 6=high) in Uganda?
Offer a very short reply. 0.08. In the year 2013, what is the difference between the Rating (1=low 6=high) in East Asia (developing only) and Rating (1=low 6=high) in Middle income?
Make the answer very short. -0.2. In the year 2013, what is the difference between the Rating (1=low 6=high) of East Asia (developing only) and Rating (1=low 6=high) of Sierra Leone?
Your answer should be very brief. 0.37. In the year 2013, what is the difference between the Rating (1=low 6=high) in East Asia (developing only) and Rating (1=low 6=high) in Uganda?
Give a very brief answer. -0.13. In the year 2013, what is the difference between the Rating (1=low 6=high) in Middle income and Rating (1=low 6=high) in Sierra Leone?
Offer a terse response. 0.57. In the year 2013, what is the difference between the Rating (1=low 6=high) in Middle income and Rating (1=low 6=high) in Uganda?
Keep it short and to the point. 0.07. In the year 2013, what is the difference between the Rating (1=low 6=high) in Sierra Leone and Rating (1=low 6=high) in Uganda?
Give a very brief answer. -0.5. In the year 2014, what is the difference between the Rating (1=low 6=high) in East Asia (developing only) and Rating (1=low 6=high) in Middle income?
Make the answer very short. -0.15. In the year 2014, what is the difference between the Rating (1=low 6=high) of East Asia (developing only) and Rating (1=low 6=high) of Sierra Leone?
Your answer should be compact. 0.4. In the year 2014, what is the difference between the Rating (1=low 6=high) in Middle income and Rating (1=low 6=high) in Sierra Leone?
Provide a short and direct response. 0.55. In the year 2014, what is the difference between the Rating (1=low 6=high) of Middle income and Rating (1=low 6=high) of Uganda?
Make the answer very short. 0.05. What is the ratio of the Rating (1=low 6=high) in East Asia (developing only) in 2007 to that in 2008?
Make the answer very short. 0.99. What is the ratio of the Rating (1=low 6=high) of Uganda in 2007 to that in 2008?
Offer a terse response. 0.86. What is the ratio of the Rating (1=low 6=high) of East Asia (developing only) in 2007 to that in 2009?
Offer a very short reply. 0.93. What is the ratio of the Rating (1=low 6=high) in Middle income in 2007 to that in 2009?
Your answer should be compact. 0.98. What is the ratio of the Rating (1=low 6=high) in East Asia (developing only) in 2007 to that in 2010?
Offer a very short reply. 0.9. What is the ratio of the Rating (1=low 6=high) of Middle income in 2007 to that in 2010?
Provide a short and direct response. 0.98. What is the ratio of the Rating (1=low 6=high) in Sierra Leone in 2007 to that in 2010?
Offer a very short reply. 0.83. What is the ratio of the Rating (1=low 6=high) of Uganda in 2007 to that in 2010?
Provide a short and direct response. 0.86. What is the ratio of the Rating (1=low 6=high) of East Asia (developing only) in 2007 to that in 2011?
Provide a short and direct response. 0.92. What is the ratio of the Rating (1=low 6=high) in Middle income in 2007 to that in 2011?
Offer a very short reply. 0.99. What is the ratio of the Rating (1=low 6=high) in Uganda in 2007 to that in 2011?
Provide a succinct answer. 0.86. What is the ratio of the Rating (1=low 6=high) of East Asia (developing only) in 2007 to that in 2012?
Keep it short and to the point. 0.94. What is the ratio of the Rating (1=low 6=high) in Sierra Leone in 2007 to that in 2012?
Provide a succinct answer. 0.83. What is the ratio of the Rating (1=low 6=high) in Uganda in 2007 to that in 2012?
Provide a succinct answer. 0.86. What is the ratio of the Rating (1=low 6=high) in East Asia (developing only) in 2007 to that in 2013?
Ensure brevity in your answer.  0.95. What is the ratio of the Rating (1=low 6=high) in Uganda in 2007 to that in 2013?
Make the answer very short. 0.86. What is the ratio of the Rating (1=low 6=high) of East Asia (developing only) in 2007 to that in 2014?
Give a very brief answer. 0.94. What is the ratio of the Rating (1=low 6=high) of Uganda in 2007 to that in 2014?
Provide a succinct answer. 0.86. What is the ratio of the Rating (1=low 6=high) of East Asia (developing only) in 2008 to that in 2009?
Make the answer very short. 0.95. What is the ratio of the Rating (1=low 6=high) of Sierra Leone in 2008 to that in 2009?
Keep it short and to the point. 1. What is the ratio of the Rating (1=low 6=high) of Uganda in 2008 to that in 2009?
Keep it short and to the point. 1. What is the ratio of the Rating (1=low 6=high) of East Asia (developing only) in 2008 to that in 2010?
Your answer should be compact. 0.91. What is the ratio of the Rating (1=low 6=high) of Middle income in 2008 to that in 2010?
Make the answer very short. 0.98. What is the ratio of the Rating (1=low 6=high) of Uganda in 2008 to that in 2010?
Make the answer very short. 1. What is the ratio of the Rating (1=low 6=high) in East Asia (developing only) in 2008 to that in 2011?
Your response must be concise. 0.93. What is the ratio of the Rating (1=low 6=high) of East Asia (developing only) in 2008 to that in 2012?
Provide a short and direct response. 0.95. What is the ratio of the Rating (1=low 6=high) in East Asia (developing only) in 2008 to that in 2013?
Provide a short and direct response. 0.96. What is the ratio of the Rating (1=low 6=high) in Middle income in 2008 to that in 2013?
Make the answer very short. 0.99. What is the ratio of the Rating (1=low 6=high) in Sierra Leone in 2008 to that in 2013?
Offer a very short reply. 0.83. What is the ratio of the Rating (1=low 6=high) of East Asia (developing only) in 2008 to that in 2014?
Provide a succinct answer. 0.95. What is the ratio of the Rating (1=low 6=high) in Middle income in 2008 to that in 2014?
Your answer should be compact. 1. What is the ratio of the Rating (1=low 6=high) in Sierra Leone in 2008 to that in 2014?
Your answer should be very brief. 0.83. What is the ratio of the Rating (1=low 6=high) of Uganda in 2008 to that in 2014?
Offer a very short reply. 1. What is the ratio of the Rating (1=low 6=high) in East Asia (developing only) in 2009 to that in 2010?
Make the answer very short. 0.96. What is the ratio of the Rating (1=low 6=high) of Middle income in 2009 to that in 2010?
Provide a succinct answer. 0.99. What is the ratio of the Rating (1=low 6=high) in Sierra Leone in 2009 to that in 2010?
Keep it short and to the point. 0.83. What is the ratio of the Rating (1=low 6=high) of Uganda in 2009 to that in 2010?
Keep it short and to the point. 1. What is the ratio of the Rating (1=low 6=high) of East Asia (developing only) in 2009 to that in 2011?
Your answer should be very brief. 0.98. What is the ratio of the Rating (1=low 6=high) in Sierra Leone in 2009 to that in 2011?
Make the answer very short. 0.83. What is the ratio of the Rating (1=low 6=high) of Uganda in 2009 to that in 2011?
Offer a terse response. 1. What is the ratio of the Rating (1=low 6=high) in Sierra Leone in 2009 to that in 2012?
Your answer should be compact. 0.83. What is the ratio of the Rating (1=low 6=high) of Uganda in 2009 to that in 2012?
Ensure brevity in your answer.  1. What is the ratio of the Rating (1=low 6=high) in East Asia (developing only) in 2009 to that in 2013?
Your answer should be very brief. 1.01. What is the ratio of the Rating (1=low 6=high) of Middle income in 2009 to that in 2014?
Your answer should be compact. 1.01. What is the ratio of the Rating (1=low 6=high) of East Asia (developing only) in 2010 to that in 2011?
Provide a short and direct response. 1.02. What is the ratio of the Rating (1=low 6=high) of Middle income in 2010 to that in 2011?
Make the answer very short. 1.01. What is the ratio of the Rating (1=low 6=high) of Sierra Leone in 2010 to that in 2011?
Ensure brevity in your answer.  1. What is the ratio of the Rating (1=low 6=high) in East Asia (developing only) in 2010 to that in 2012?
Provide a short and direct response. 1.04. What is the ratio of the Rating (1=low 6=high) of Middle income in 2010 to that in 2012?
Your answer should be compact. 1.01. What is the ratio of the Rating (1=low 6=high) of East Asia (developing only) in 2010 to that in 2013?
Your answer should be very brief. 1.05. What is the ratio of the Rating (1=low 6=high) in Middle income in 2010 to that in 2013?
Give a very brief answer. 1.01. What is the ratio of the Rating (1=low 6=high) in Sierra Leone in 2010 to that in 2013?
Your response must be concise. 1. What is the ratio of the Rating (1=low 6=high) in Uganda in 2010 to that in 2013?
Offer a terse response. 1. What is the ratio of the Rating (1=low 6=high) of East Asia (developing only) in 2010 to that in 2014?
Offer a terse response. 1.04. What is the ratio of the Rating (1=low 6=high) in Middle income in 2010 to that in 2014?
Give a very brief answer. 1.02. What is the ratio of the Rating (1=low 6=high) in Sierra Leone in 2010 to that in 2014?
Keep it short and to the point. 1. What is the ratio of the Rating (1=low 6=high) in Uganda in 2010 to that in 2014?
Offer a terse response. 1. What is the ratio of the Rating (1=low 6=high) of East Asia (developing only) in 2011 to that in 2012?
Provide a short and direct response. 1.02. What is the ratio of the Rating (1=low 6=high) in East Asia (developing only) in 2011 to that in 2013?
Keep it short and to the point. 1.03. What is the ratio of the Rating (1=low 6=high) in Middle income in 2011 to that in 2013?
Provide a short and direct response. 1. What is the ratio of the Rating (1=low 6=high) of East Asia (developing only) in 2011 to that in 2014?
Keep it short and to the point. 1.02. What is the ratio of the Rating (1=low 6=high) of Uganda in 2011 to that in 2014?
Offer a terse response. 1. What is the ratio of the Rating (1=low 6=high) in East Asia (developing only) in 2012 to that in 2013?
Keep it short and to the point. 1.01. What is the ratio of the Rating (1=low 6=high) of Middle income in 2012 to that in 2014?
Offer a very short reply. 1.01. What is the ratio of the Rating (1=low 6=high) of Sierra Leone in 2012 to that in 2014?
Make the answer very short. 1. What is the ratio of the Rating (1=low 6=high) in Uganda in 2012 to that in 2014?
Offer a very short reply. 1. What is the ratio of the Rating (1=low 6=high) of East Asia (developing only) in 2013 to that in 2014?
Keep it short and to the point. 0.99. What is the ratio of the Rating (1=low 6=high) of Middle income in 2013 to that in 2014?
Make the answer very short. 1. What is the ratio of the Rating (1=low 6=high) of Sierra Leone in 2013 to that in 2014?
Ensure brevity in your answer.  1. What is the ratio of the Rating (1=low 6=high) of Uganda in 2013 to that in 2014?
Your answer should be compact. 1. What is the difference between the highest and the second highest Rating (1=low 6=high) of East Asia (developing only)?
Offer a very short reply. 0.08. What is the difference between the highest and the second highest Rating (1=low 6=high) in Middle income?
Your answer should be compact. 0.02. What is the difference between the highest and the second highest Rating (1=low 6=high) of Sierra Leone?
Offer a terse response. 0. What is the difference between the highest and the lowest Rating (1=low 6=high) in East Asia (developing only)?
Offer a terse response. 0.36. What is the difference between the highest and the lowest Rating (1=low 6=high) in Middle income?
Your answer should be very brief. 0.08. What is the difference between the highest and the lowest Rating (1=low 6=high) of Sierra Leone?
Offer a very short reply. 0.5. 